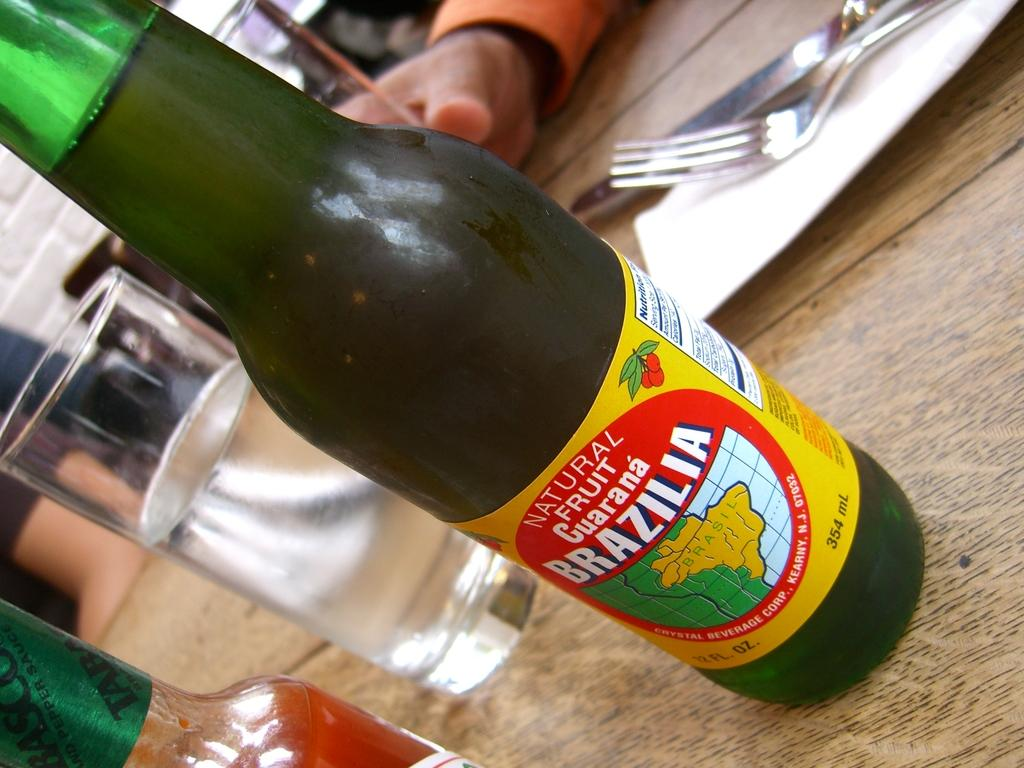<image>
Provide a brief description of the given image. a bottle of natural fruit guarana brazilia on a yellow label 